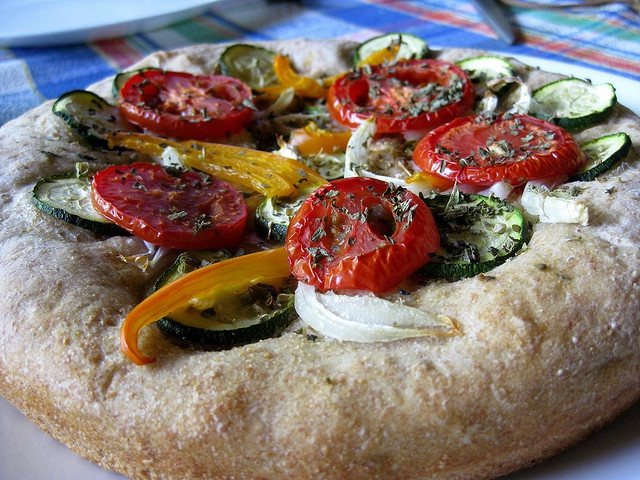Describe the objects in this image and their specific colors. I can see pizza in lightblue, darkgray, maroon, black, and lightgray tones and knife in lightblue, gray, and darkblue tones in this image. 